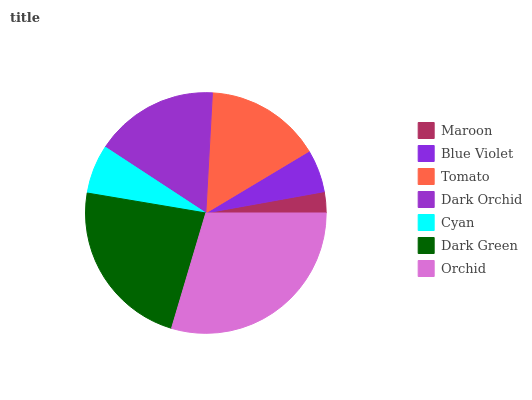Is Maroon the minimum?
Answer yes or no. Yes. Is Orchid the maximum?
Answer yes or no. Yes. Is Blue Violet the minimum?
Answer yes or no. No. Is Blue Violet the maximum?
Answer yes or no. No. Is Blue Violet greater than Maroon?
Answer yes or no. Yes. Is Maroon less than Blue Violet?
Answer yes or no. Yes. Is Maroon greater than Blue Violet?
Answer yes or no. No. Is Blue Violet less than Maroon?
Answer yes or no. No. Is Tomato the high median?
Answer yes or no. Yes. Is Tomato the low median?
Answer yes or no. Yes. Is Dark Orchid the high median?
Answer yes or no. No. Is Dark Orchid the low median?
Answer yes or no. No. 